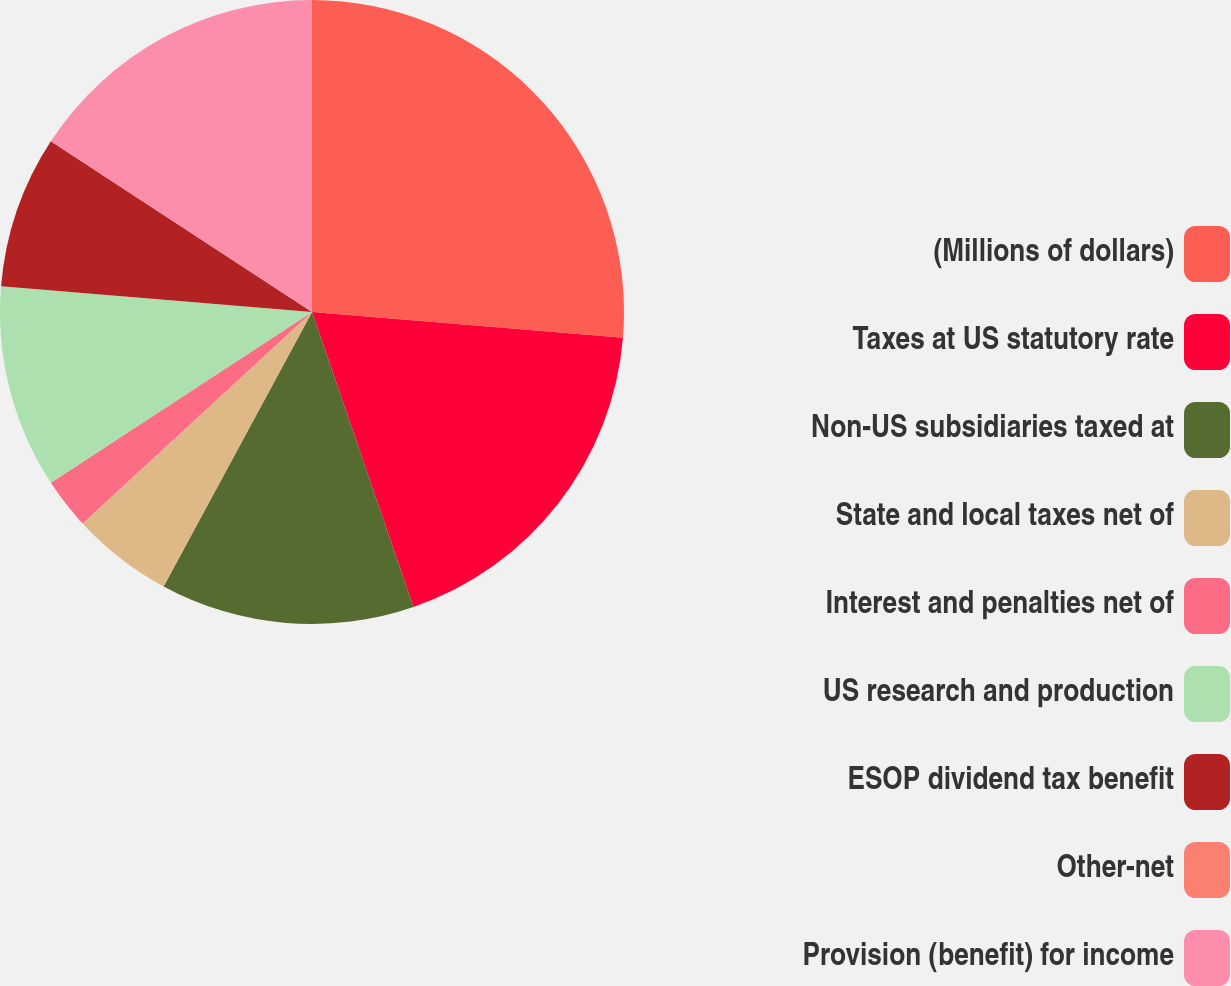<chart> <loc_0><loc_0><loc_500><loc_500><pie_chart><fcel>(Millions of dollars)<fcel>Taxes at US statutory rate<fcel>Non-US subsidiaries taxed at<fcel>State and local taxes net of<fcel>Interest and penalties net of<fcel>US research and production<fcel>ESOP dividend tax benefit<fcel>Other-net<fcel>Provision (benefit) for income<nl><fcel>26.31%<fcel>18.42%<fcel>13.16%<fcel>5.26%<fcel>2.63%<fcel>10.53%<fcel>7.9%<fcel>0.0%<fcel>15.79%<nl></chart> 